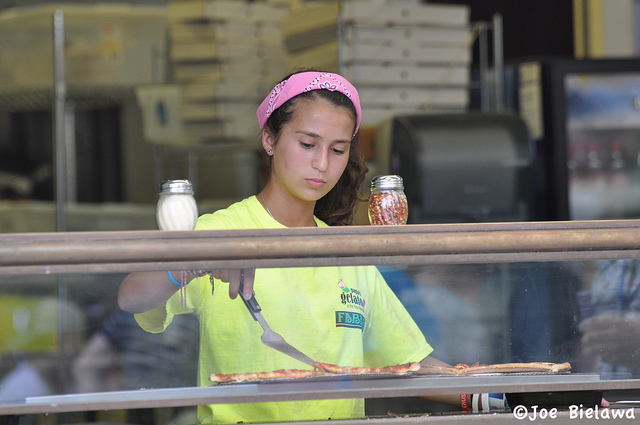Identify the text contained in this image. Joe Bielawa FAR 